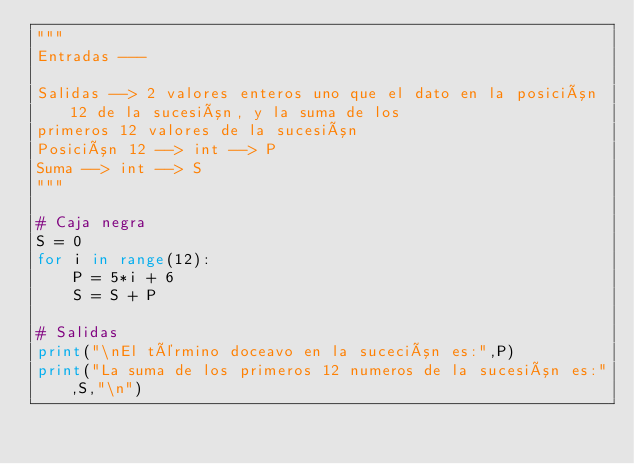Convert code to text. <code><loc_0><loc_0><loc_500><loc_500><_Python_>"""
Entradas ---

Salidas --> 2 valores enteros uno que el dato en la posición 12 de la sucesión, y la suma de los 
primeros 12 valores de la sucesión
Posición 12 --> int --> P
Suma --> int --> S
"""

# Caja negra
S = 0
for i in range(12):
    P = 5*i + 6
    S = S + P
    
# Salidas
print("\nEl término doceavo en la suceción es:",P) 
print("La suma de los primeros 12 numeros de la sucesión es:",S,"\n") </code> 